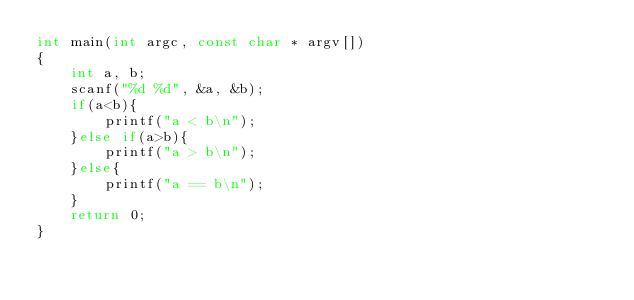<code> <loc_0><loc_0><loc_500><loc_500><_C_>int main(int argc, const char * argv[])
{
    int a, b;
    scanf("%d %d", &a, &b);
    if(a<b){
        printf("a < b\n");
    }else if(a>b){
        printf("a > b\n");
    }else{
        printf("a == b\n");
    }
    return 0;
}</code> 